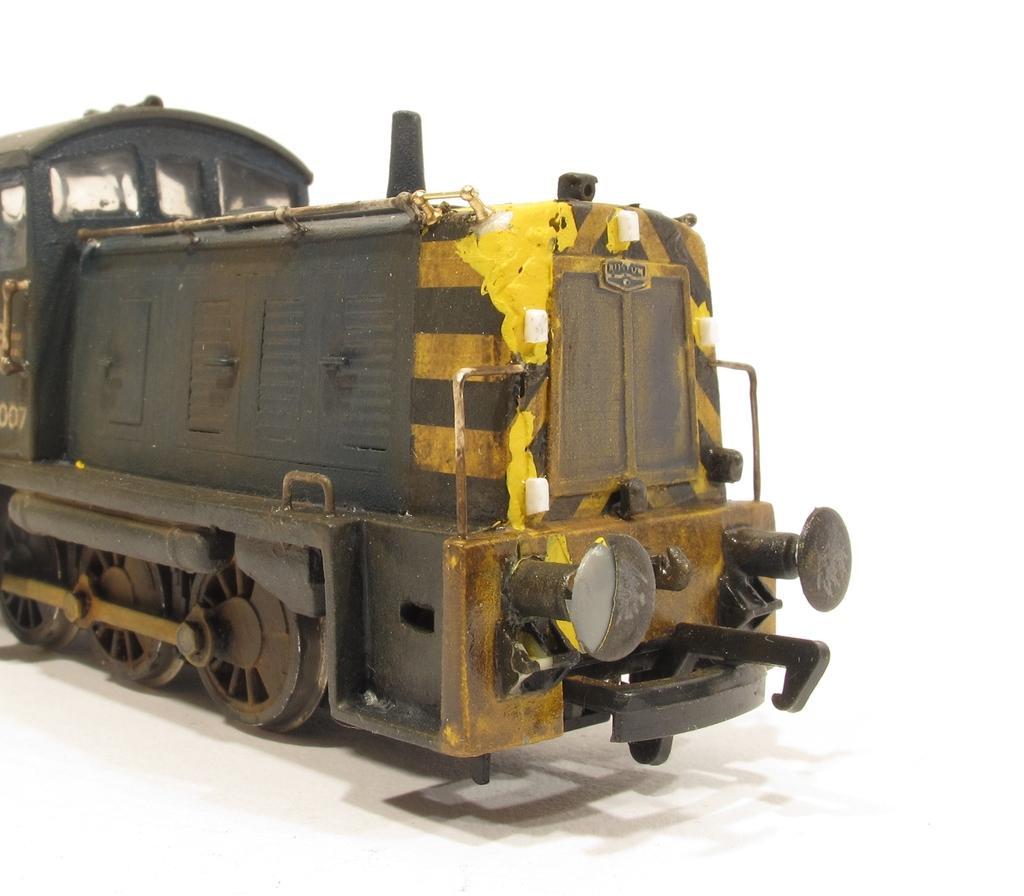How would you summarize this image in a sentence or two? In this picture, we see the engine of the train. It is in black and yellow color. At the bottom, it is white in color. In the background, it is white in color. 